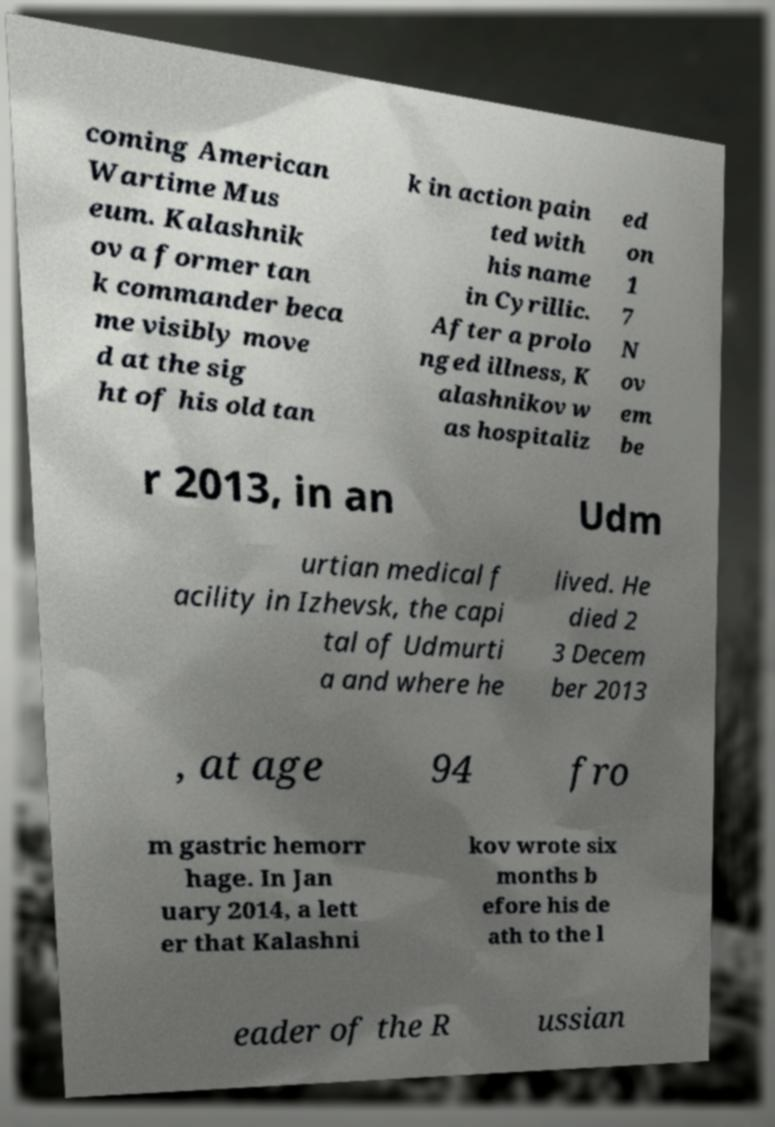What messages or text are displayed in this image? I need them in a readable, typed format. coming American Wartime Mus eum. Kalashnik ov a former tan k commander beca me visibly move d at the sig ht of his old tan k in action pain ted with his name in Cyrillic. After a prolo nged illness, K alashnikov w as hospitaliz ed on 1 7 N ov em be r 2013, in an Udm urtian medical f acility in Izhevsk, the capi tal of Udmurti a and where he lived. He died 2 3 Decem ber 2013 , at age 94 fro m gastric hemorr hage. In Jan uary 2014, a lett er that Kalashni kov wrote six months b efore his de ath to the l eader of the R ussian 